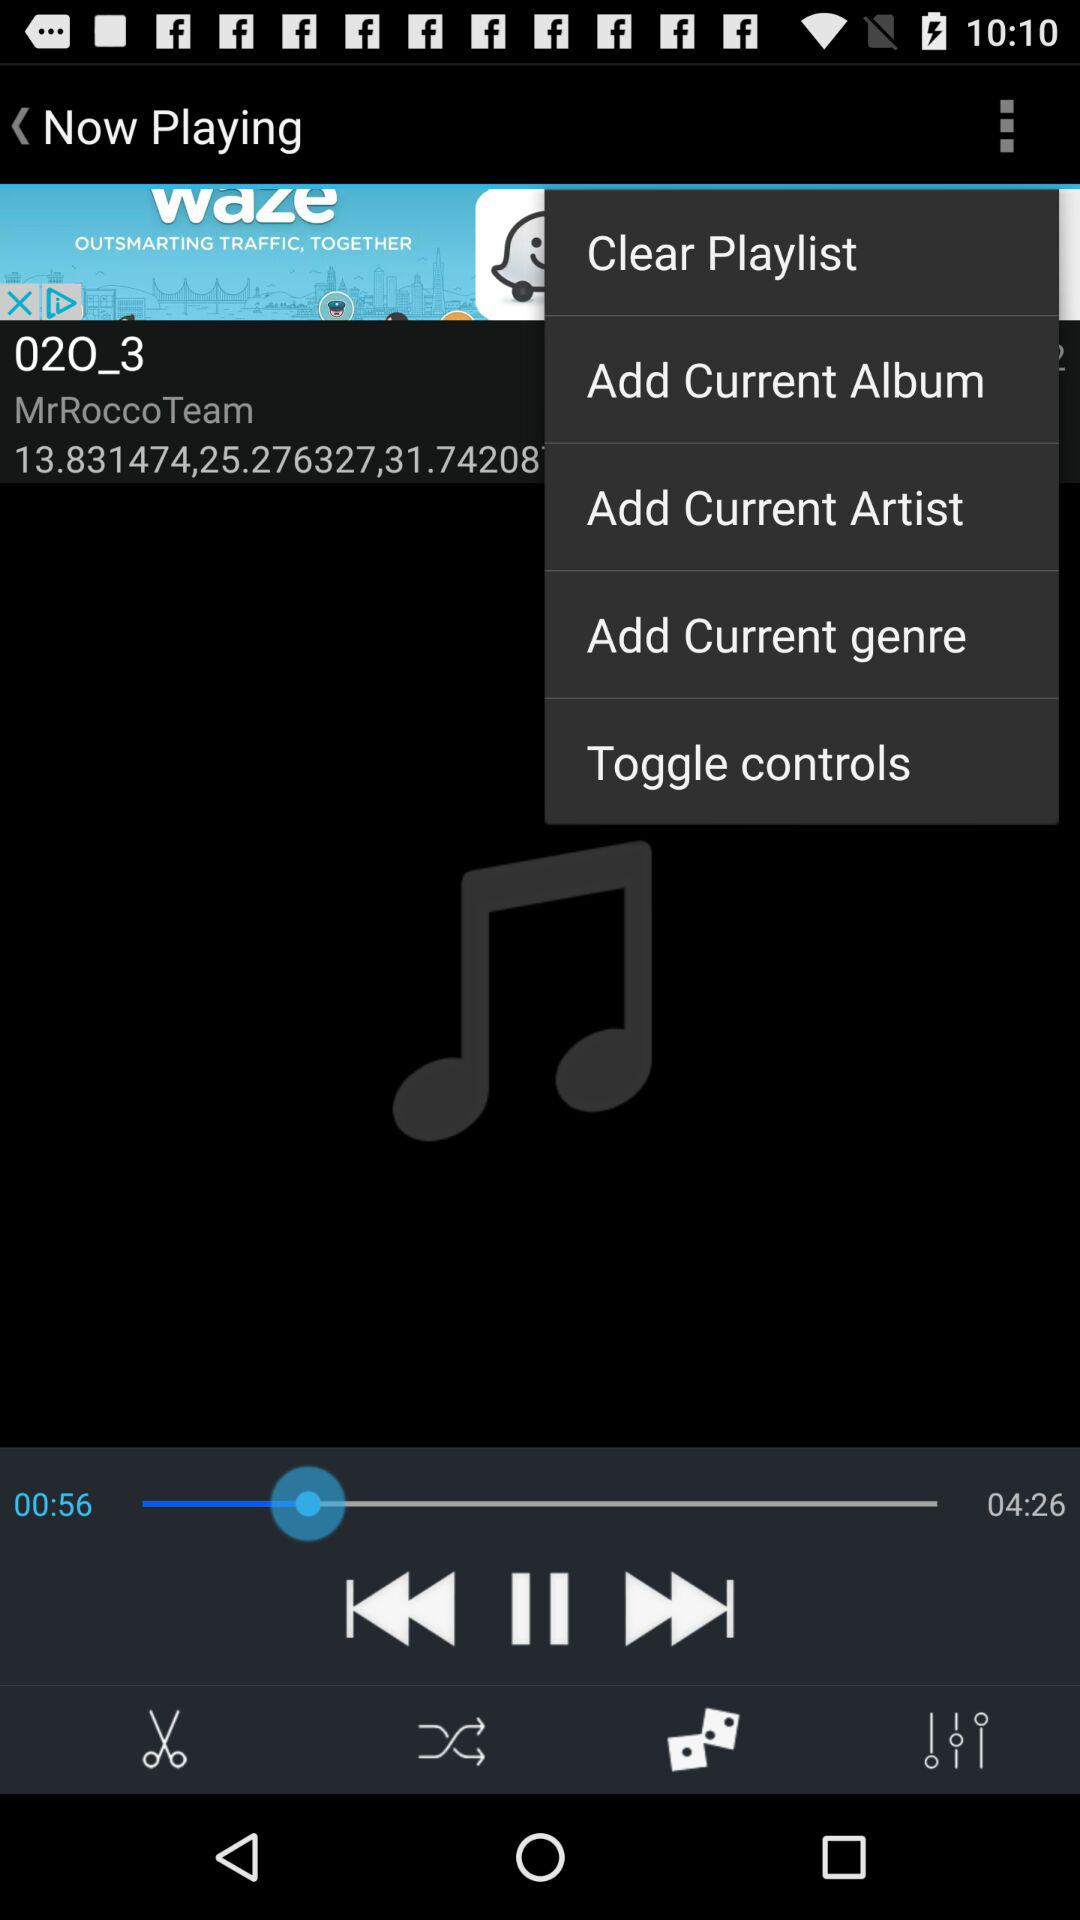What is the total duration? The total duration is 4 minutes and 26 seconds. 